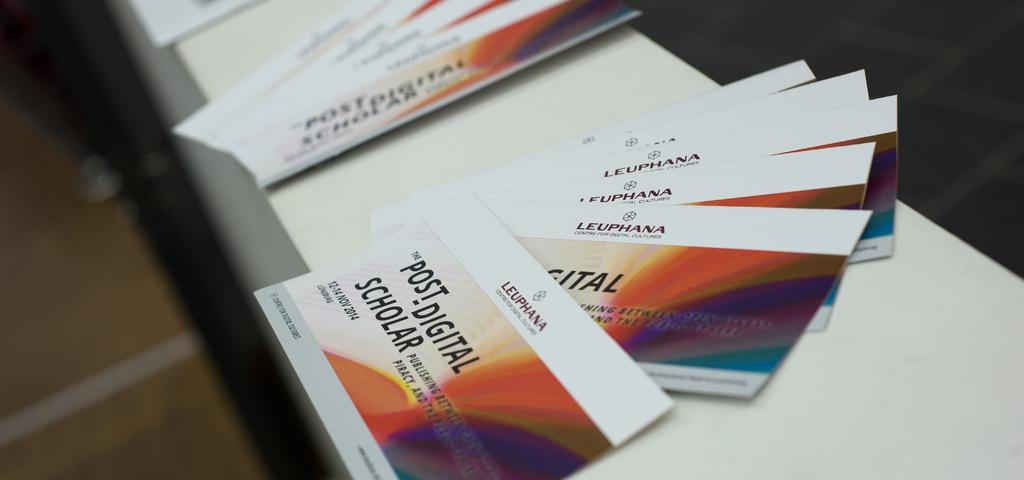<image>
Offer a succinct explanation of the picture presented. Some cards advertise a presentation at the Leuphana Centre for Digital Cultures. 